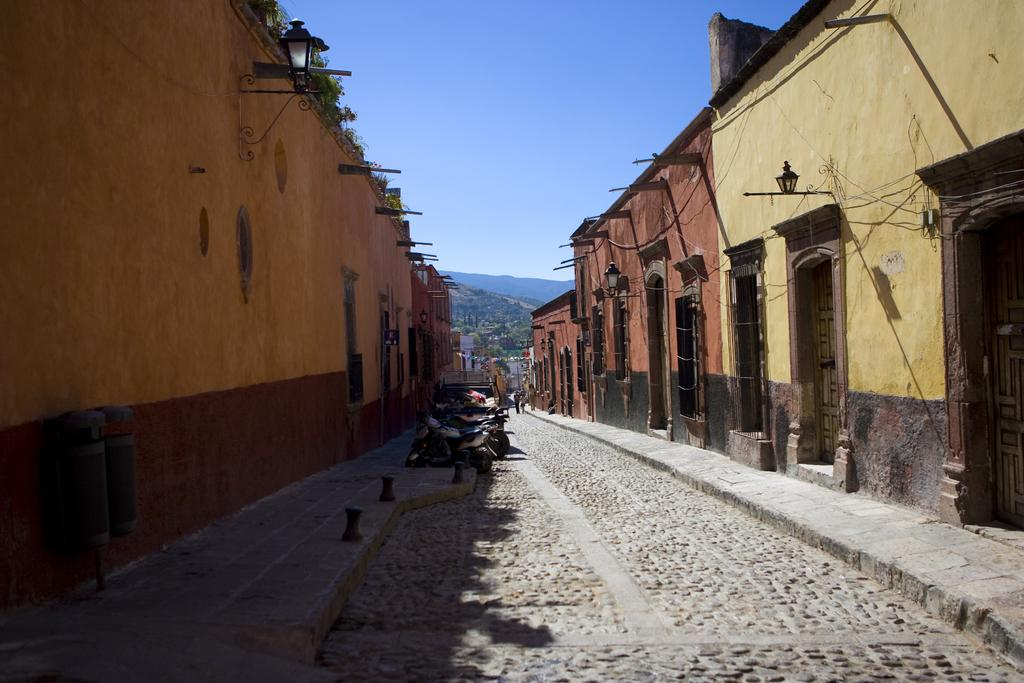What is the main subject of the image? The main subject of the image is an empty road. What can be seen on the road? Many bikes are parked on the road. What else is visible in the image besides the road and bikes? There are buildings visible in the image. Can you describe the position of the building in relation to the parked bikes? There is a building in front of the parked bikes. How many ladybugs can be seen jumping on the parked bikes in the image? There are no ladybugs visible in the image, and therefore no such activity can be observed. 